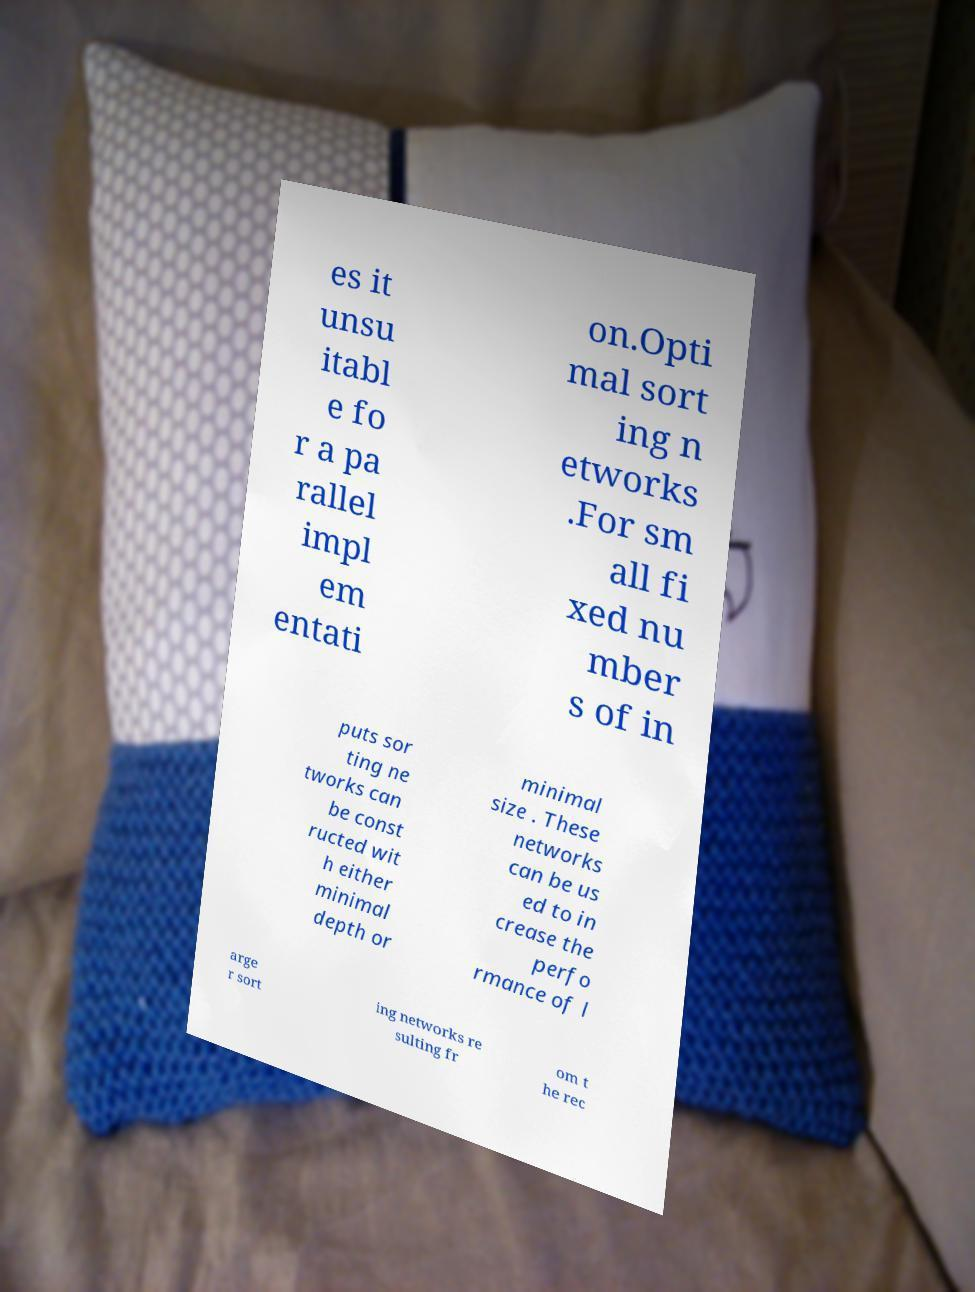Please identify and transcribe the text found in this image. es it unsu itabl e fo r a pa rallel impl em entati on.Opti mal sort ing n etworks .For sm all fi xed nu mber s of in puts sor ting ne tworks can be const ructed wit h either minimal depth or minimal size . These networks can be us ed to in crease the perfo rmance of l arge r sort ing networks re sulting fr om t he rec 